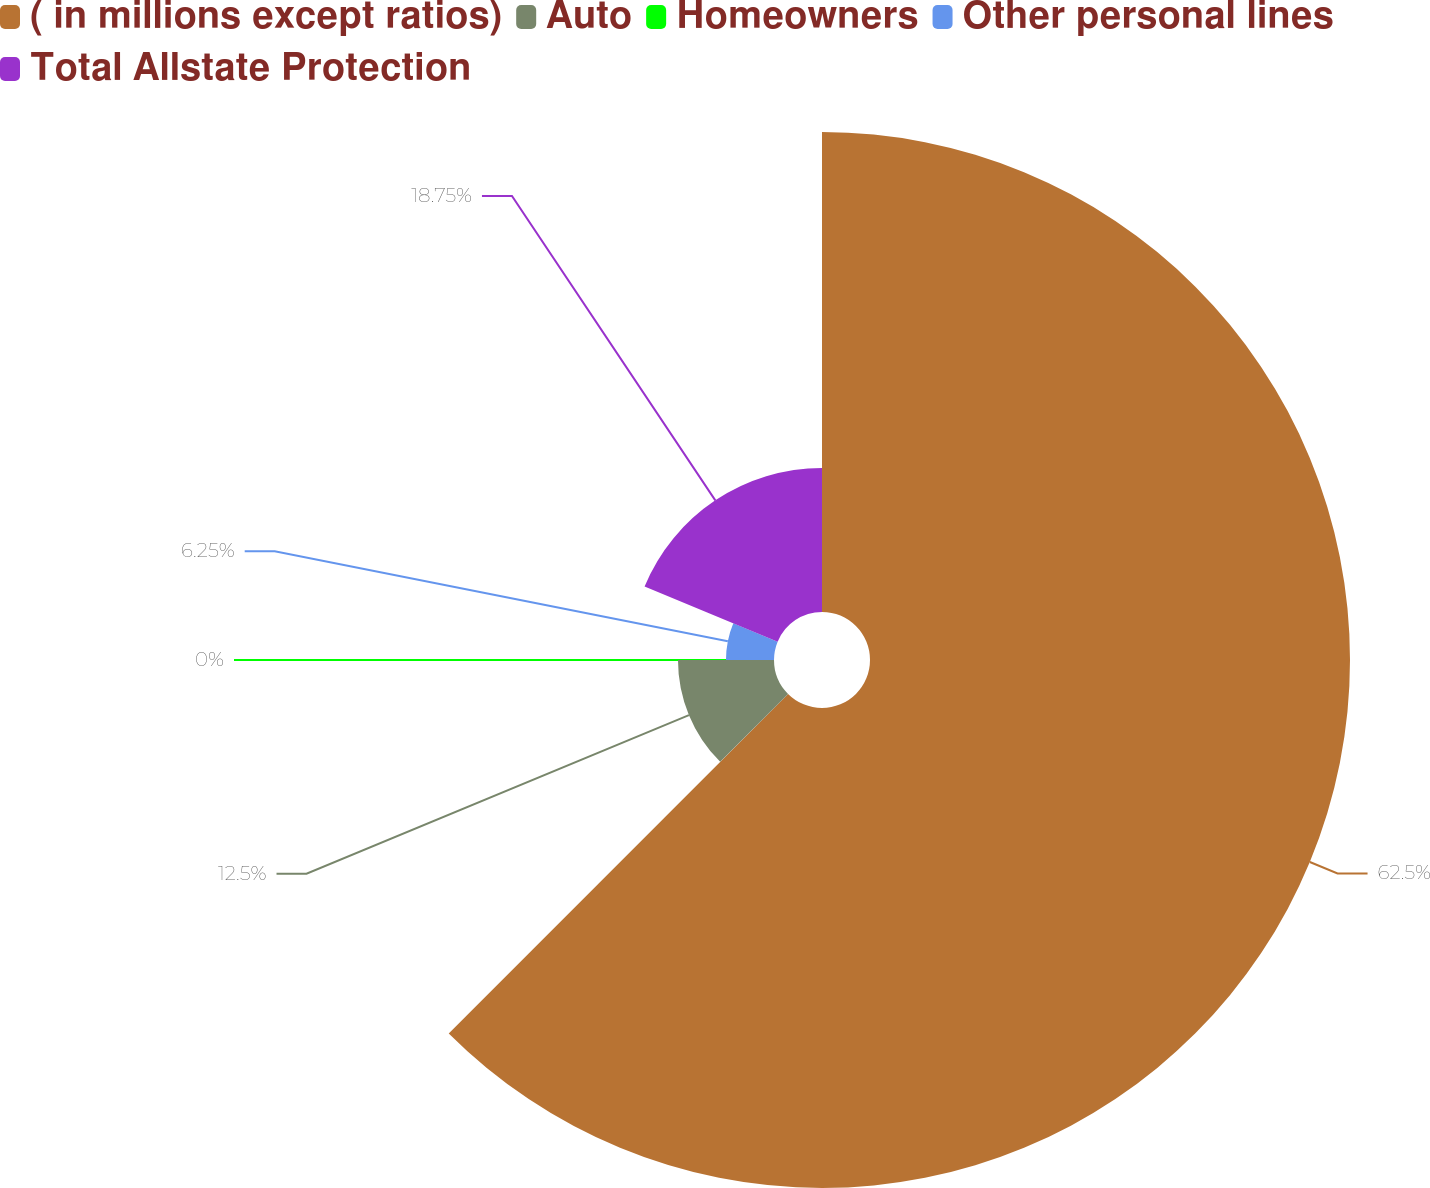Convert chart. <chart><loc_0><loc_0><loc_500><loc_500><pie_chart><fcel>( in millions except ratios)<fcel>Auto<fcel>Homeowners<fcel>Other personal lines<fcel>Total Allstate Protection<nl><fcel>62.49%<fcel>12.5%<fcel>0.0%<fcel>6.25%<fcel>18.75%<nl></chart> 